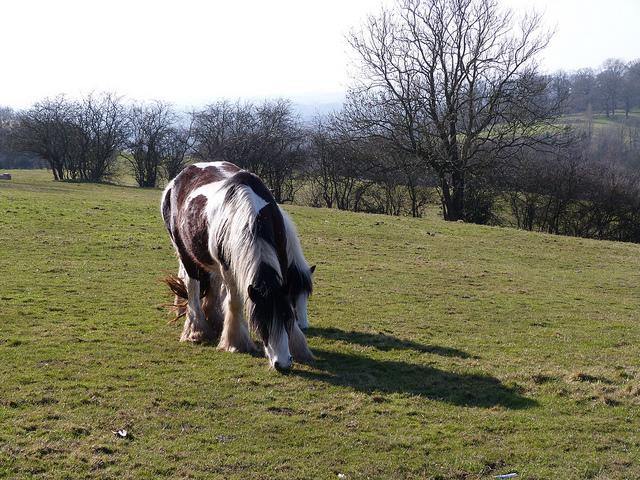Is the horse facing uphill or downhill?
Write a very short answer. Downhill. What is covering the ground?
Give a very brief answer. Grass. Are they out in a pasture?
Concise answer only. Yes. What breed of horse is in the picture?
Short answer required. Shetland pony. 